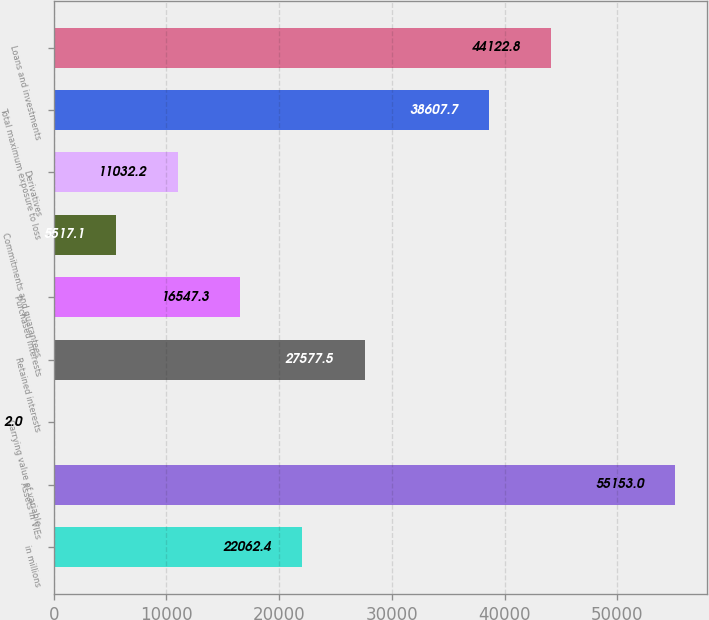Convert chart. <chart><loc_0><loc_0><loc_500><loc_500><bar_chart><fcel>in millions<fcel>Assets in VIEs<fcel>Carrying value of variable<fcel>Retained interests<fcel>Purchased interests<fcel>Commitments and guarantees<fcel>Derivatives<fcel>Total maximum exposure to loss<fcel>Loans and investments<nl><fcel>22062.4<fcel>55153<fcel>2<fcel>27577.5<fcel>16547.3<fcel>5517.1<fcel>11032.2<fcel>38607.7<fcel>44122.8<nl></chart> 